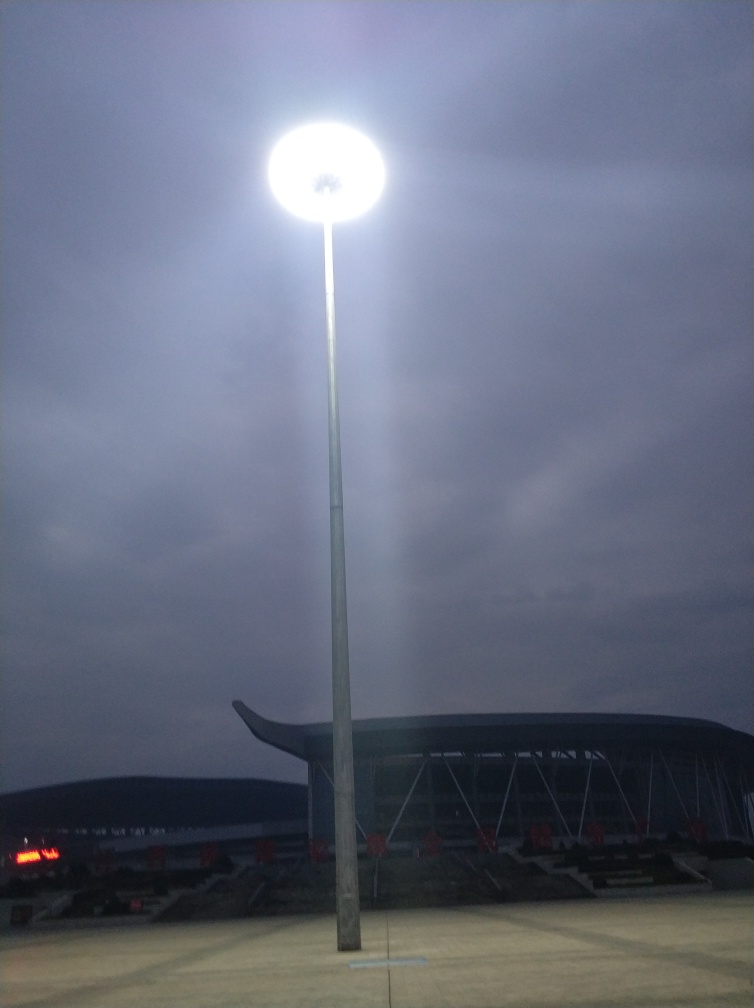What time of day does this image seem to depict? The image appears to be captured during twilight or early evening given the sky's colour and the artificial lighting from the lamppost. 